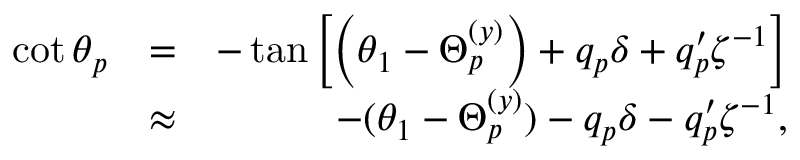Convert formula to latex. <formula><loc_0><loc_0><loc_500><loc_500>\begin{array} { r l r } { \cot \theta _ { p } } & { = } & { - \tan \left [ \left ( \theta _ { 1 } - \Theta _ { p } ^ { ( y ) } \right ) + q _ { p } \delta + q _ { p } ^ { \prime } \zeta ^ { - 1 } \right ] } \\ & { \approx } & { - ( \theta _ { 1 } - \Theta _ { p } ^ { ( y ) } ) - q _ { p } \delta - q _ { p } ^ { \prime } \zeta ^ { - 1 } , } \end{array}</formula> 